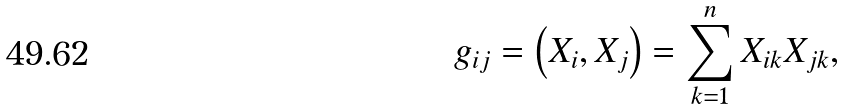Convert formula to latex. <formula><loc_0><loc_0><loc_500><loc_500>g _ { i j } = \left ( X _ { i } , X _ { j } \right ) = \sum _ { k = 1 } ^ { n } X _ { i k } X _ { j k } ,</formula> 